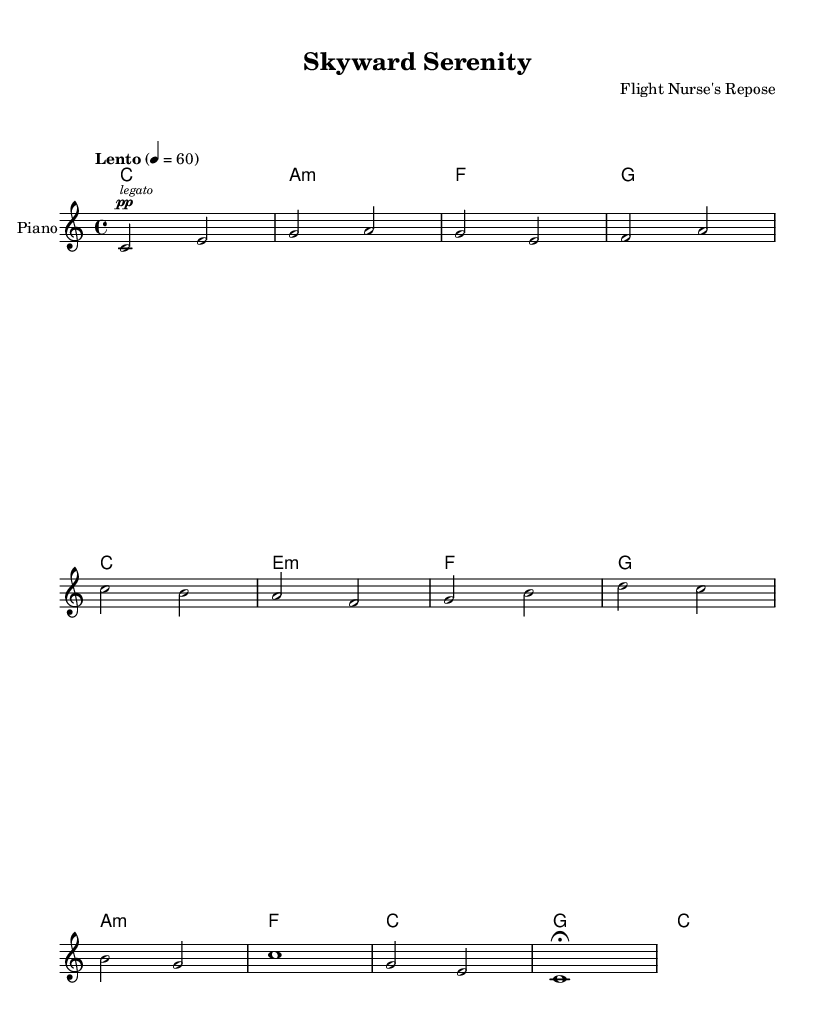What is the key signature of this music? The key signature is C major, which has no sharps or flats.
Answer: C major What is the time signature of this piece? The time signature is indicated as 4/4, meaning there are four beats in each measure.
Answer: 4/4 What is the tempo marking for this piece? The tempo marking is "Lento," which indicates a slow pace, specifically around 60 beats per minute.
Answer: Lento How many measures are in the main melody? By counting the individual groupings of notes and rests in the melody section, there are 12 measures in total.
Answer: 12 What chords are used during the first section of the harmonies? The first section includes the chords C major, A minor, F major, and G major, which frame the harmonic structure.
Answer: C, A minor, F, G What kind of mood does this soundtrack aim to evoke through its composition? The soundtrack uses soothing melodies and harmonies, resulting in a calming and serene atmosphere, appropriate for relaxation and stress relief.
Answer: Calming What specific musical technique is highlighted in the melody with the instruction "legato"? The instruction "legato" indicates that the melody should be played in a smooth, connected manner, minimizing breaks between the notes.
Answer: Legato 